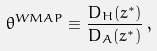<formula> <loc_0><loc_0><loc_500><loc_500>\theta ^ { W M A P } \equiv \frac { D _ { H } ( z ^ { * } ) } { D _ { A } ( z ^ { * } ) } \, ,</formula> 